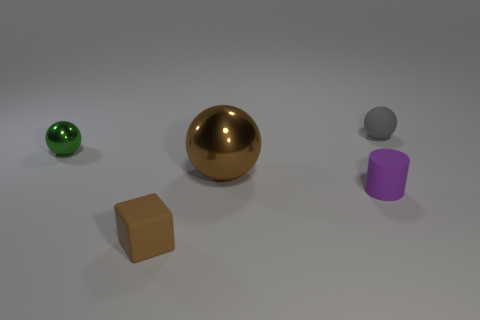Add 4 matte cylinders. How many objects exist? 9 Subtract all cylinders. How many objects are left? 4 Subtract 0 cyan spheres. How many objects are left? 5 Subtract all brown objects. Subtract all tiny spheres. How many objects are left? 1 Add 3 small green spheres. How many small green spheres are left? 4 Add 3 purple rubber objects. How many purple rubber objects exist? 4 